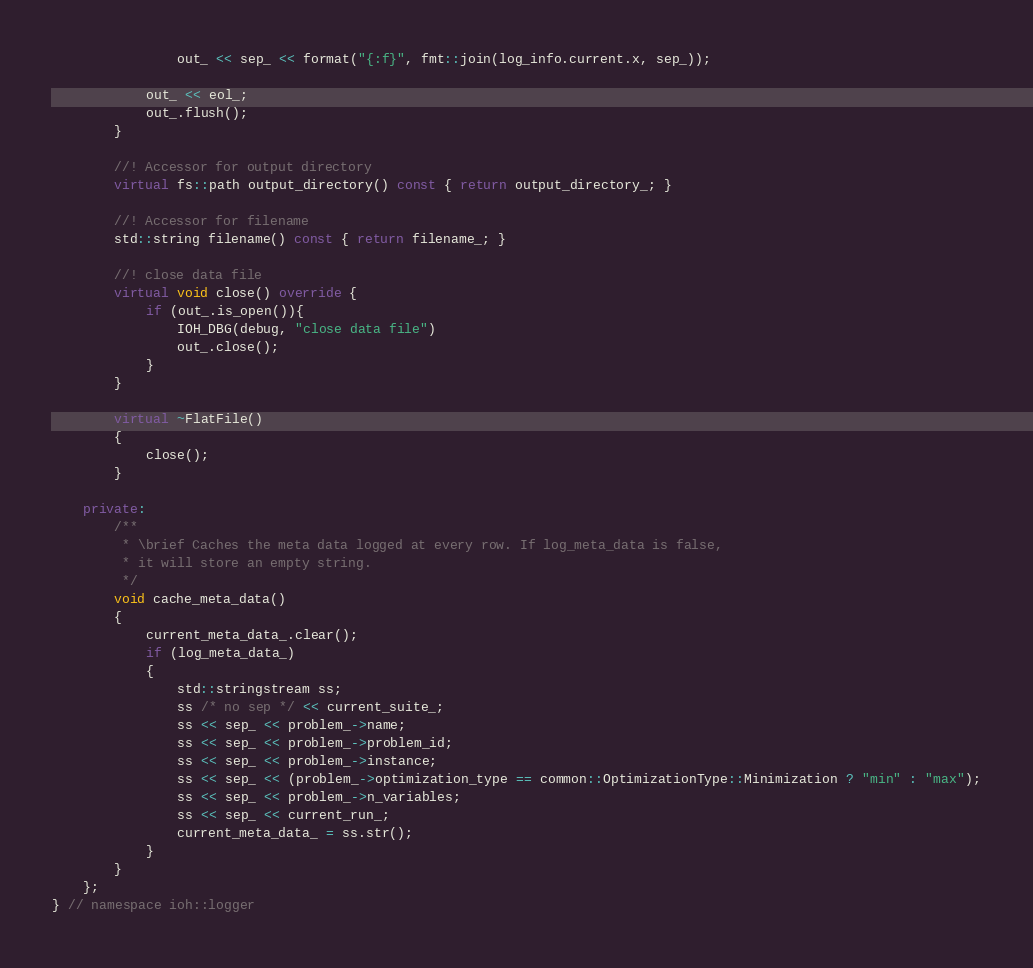Convert code to text. <code><loc_0><loc_0><loc_500><loc_500><_C++_>                out_ << sep_ << format("{:f}", fmt::join(log_info.current.x, sep_));

            out_ << eol_;
            out_.flush();
        }

        //! Accessor for output directory
        virtual fs::path output_directory() const { return output_directory_; }

        //! Accessor for filename
        std::string filename() const { return filename_; }

        //! close data file
        virtual void close() override {
            if (out_.is_open()){
                IOH_DBG(debug, "close data file")
                out_.close();
            }
        }
        
        virtual ~FlatFile()
        {
            close();
        }

    private:
        /**
         * \brief Caches the meta data logged at every row. If log_meta_data is false,
         * it will store an empty string.
         */
        void cache_meta_data()
        {
            current_meta_data_.clear();
            if (log_meta_data_)
            {
                std::stringstream ss;
                ss /* no sep */ << current_suite_;
                ss << sep_ << problem_->name;
                ss << sep_ << problem_->problem_id;
                ss << sep_ << problem_->instance;
                ss << sep_ << (problem_->optimization_type == common::OptimizationType::Minimization ? "min" : "max");
                ss << sep_ << problem_->n_variables;
                ss << sep_ << current_run_;
                current_meta_data_ = ss.str();
            }
        }
    };
} // namespace ioh::logger
</code> 